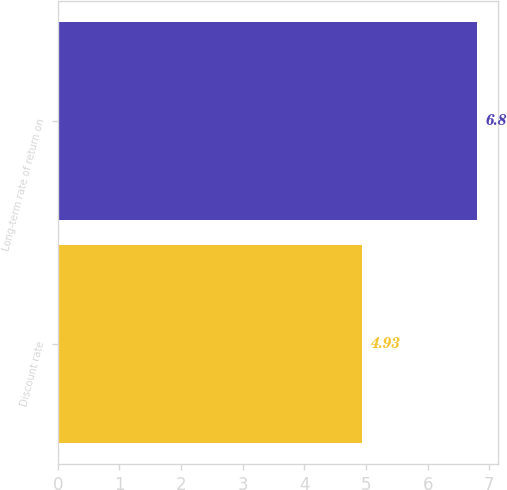Convert chart to OTSL. <chart><loc_0><loc_0><loc_500><loc_500><bar_chart><fcel>Discount rate<fcel>Long-term rate of return on<nl><fcel>4.93<fcel>6.8<nl></chart> 